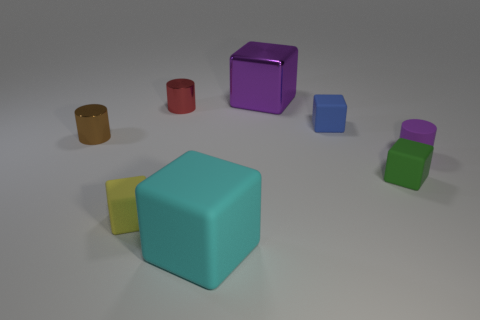What is the size of the rubber cube that is behind the small green cube?
Provide a short and direct response. Small. What is the material of the purple cube?
Provide a succinct answer. Metal. There is a purple thing that is in front of the small cylinder that is behind the brown cylinder; what shape is it?
Your answer should be very brief. Cylinder. What number of other things are the same shape as the tiny blue matte object?
Give a very brief answer. 4. Are there any big blocks in front of the matte cylinder?
Provide a succinct answer. Yes. What color is the metal cube?
Provide a succinct answer. Purple. Is the color of the large metal thing the same as the cylinder to the right of the big metal object?
Provide a succinct answer. Yes. Are there any matte things that have the same size as the brown metallic thing?
Your response must be concise. Yes. There is a metallic block that is the same color as the small rubber cylinder; what size is it?
Your answer should be very brief. Large. What material is the small cylinder to the right of the big rubber object?
Provide a succinct answer. Rubber. 